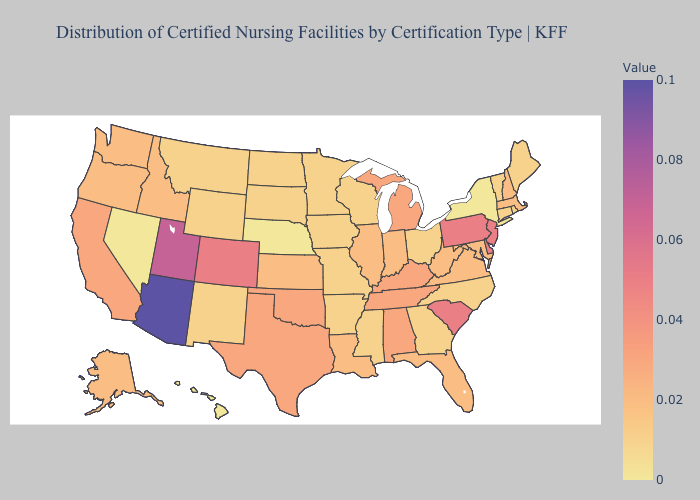Does Pennsylvania have the highest value in the Northeast?
Be succinct. Yes. Does Washington have a higher value than Nebraska?
Give a very brief answer. Yes. Does Arizona have the highest value in the USA?
Short answer required. Yes. Does New York have the lowest value in the Northeast?
Be succinct. Yes. Does Pennsylvania have the highest value in the Northeast?
Short answer required. Yes. Among the states that border Vermont , which have the highest value?
Short answer required. Massachusetts, New Hampshire. Does California have the lowest value in the USA?
Give a very brief answer. No. 